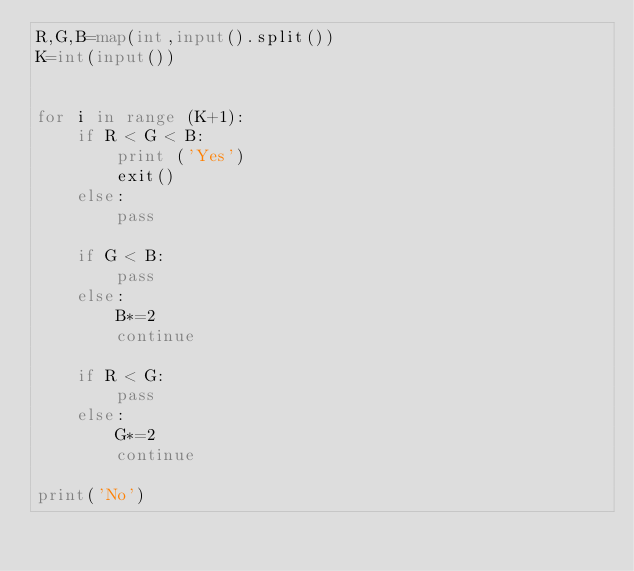Convert code to text. <code><loc_0><loc_0><loc_500><loc_500><_Python_>R,G,B=map(int,input().split())
K=int(input())


for i in range (K+1):
    if R < G < B:
        print ('Yes')
        exit()
    else:
        pass
    
    if G < B:
        pass
    else:
        B*=2
        continue

    if R < G:
        pass
    else:
        G*=2
        continue

print('No')
</code> 